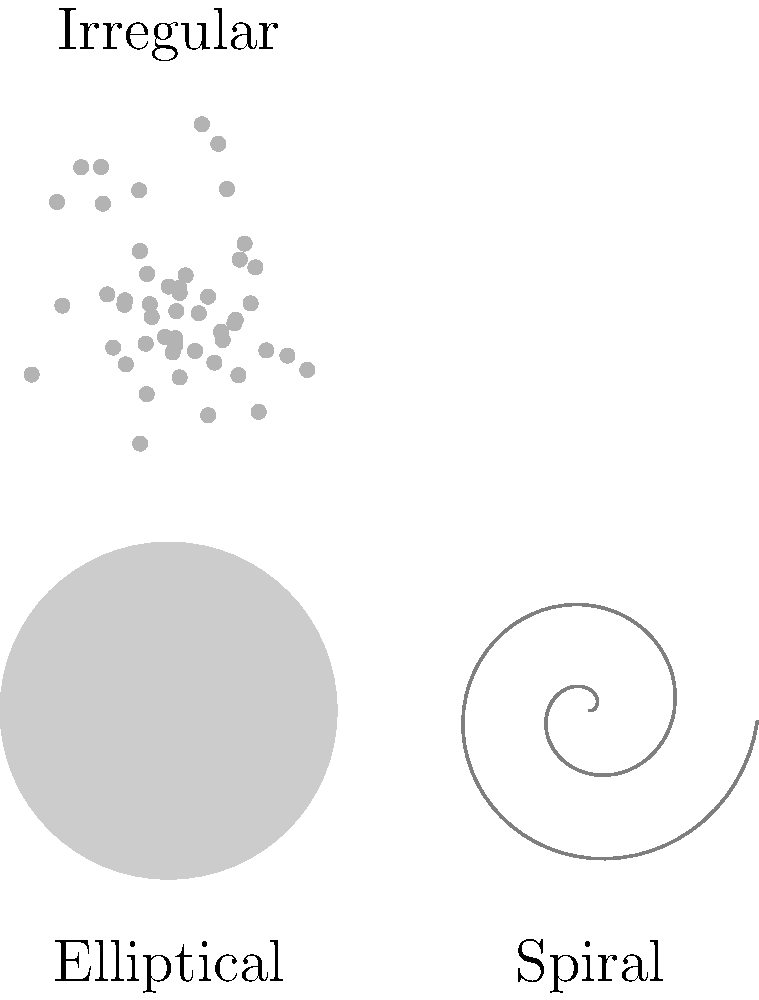As a science writer inspired by your astrophysicist teacher, you're well-versed in galactic structures. The image above shows three main types of galaxies. Which type is characterized by a distinct spiral arm structure and is often associated with active star formation? To answer this question, let's analyze the three types of galaxies shown in the image:

1. Elliptical Galaxy (bottom left):
   - Smooth, featureless appearance
   - Elliptical or spheroidal shape
   - Generally composed of older stars with little ongoing star formation

2. Spiral Galaxy (bottom right):
   - Distinct spiral arm structure
   - Flat disk with a central bulge
   - Arms contain gas, dust, and younger stars
   - Active star formation occurs in the spiral arms

3. Irregular Galaxy (top):
   - No definite shape or structure
   - Often result from galactic interactions or mergers
   - Can have regions of active star formation

Among these three types, the spiral galaxy is characterized by its distinct spiral arm structure. These arms are regions of higher density where star formation is actively occurring. The gas and dust in the spiral arms provide the raw materials for new stars to form.

The spiral structure is maintained by density waves that move through the galactic disk, compressing the interstellar medium and triggering star formation. This ongoing process of star formation in the spiral arms gives these galaxies their characteristic blue color in the arms, as young, hot stars emit more blue light.
Answer: Spiral galaxy 